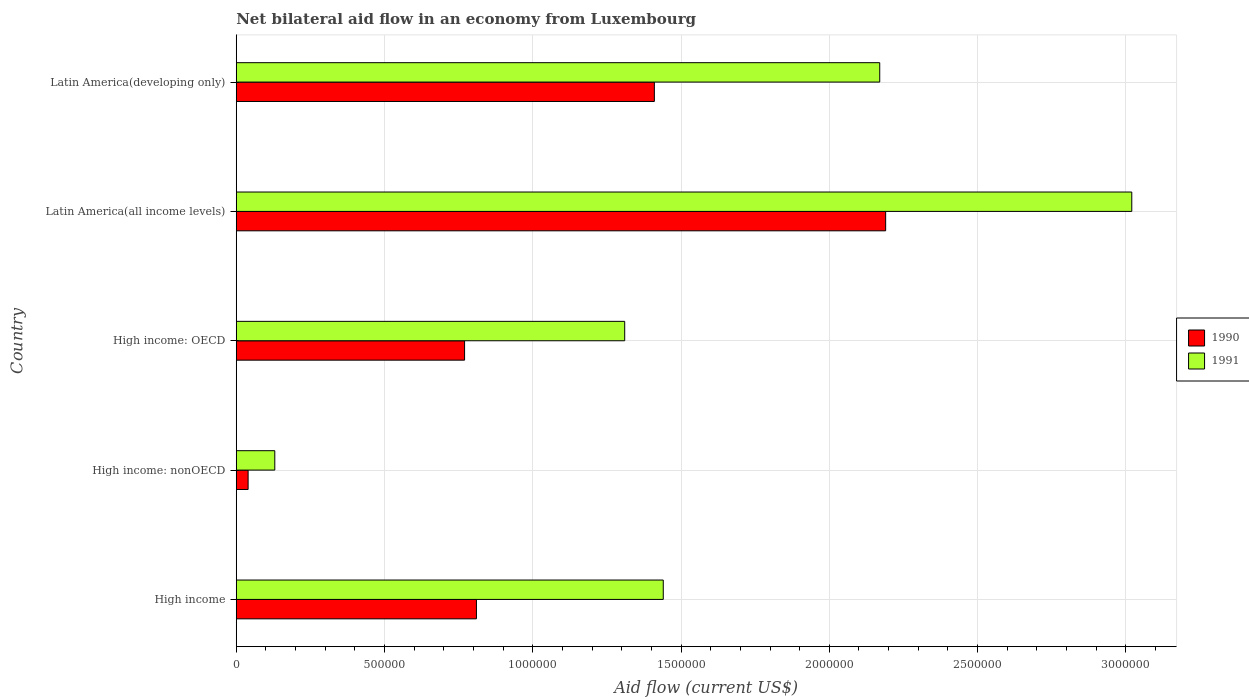How many groups of bars are there?
Ensure brevity in your answer.  5. Are the number of bars per tick equal to the number of legend labels?
Your answer should be compact. Yes. Are the number of bars on each tick of the Y-axis equal?
Your answer should be compact. Yes. How many bars are there on the 1st tick from the top?
Offer a terse response. 2. What is the label of the 1st group of bars from the top?
Your response must be concise. Latin America(developing only). Across all countries, what is the maximum net bilateral aid flow in 1991?
Ensure brevity in your answer.  3.02e+06. In which country was the net bilateral aid flow in 1991 maximum?
Provide a succinct answer. Latin America(all income levels). In which country was the net bilateral aid flow in 1991 minimum?
Give a very brief answer. High income: nonOECD. What is the total net bilateral aid flow in 1990 in the graph?
Offer a terse response. 5.22e+06. What is the difference between the net bilateral aid flow in 1991 in High income and that in Latin America(developing only)?
Keep it short and to the point. -7.30e+05. What is the difference between the net bilateral aid flow in 1990 in Latin America(all income levels) and the net bilateral aid flow in 1991 in High income: OECD?
Provide a short and direct response. 8.80e+05. What is the average net bilateral aid flow in 1991 per country?
Provide a short and direct response. 1.61e+06. What is the difference between the net bilateral aid flow in 1990 and net bilateral aid flow in 1991 in High income: nonOECD?
Give a very brief answer. -9.00e+04. In how many countries, is the net bilateral aid flow in 1990 greater than 1300000 US$?
Your answer should be compact. 2. What is the ratio of the net bilateral aid flow in 1990 in High income: nonOECD to that in Latin America(all income levels)?
Make the answer very short. 0.02. Is the net bilateral aid flow in 1990 in High income: nonOECD less than that in Latin America(developing only)?
Ensure brevity in your answer.  Yes. What is the difference between the highest and the second highest net bilateral aid flow in 1991?
Your answer should be very brief. 8.50e+05. What is the difference between the highest and the lowest net bilateral aid flow in 1990?
Keep it short and to the point. 2.15e+06. Is the sum of the net bilateral aid flow in 1990 in High income and High income: nonOECD greater than the maximum net bilateral aid flow in 1991 across all countries?
Make the answer very short. No. What does the 2nd bar from the top in Latin America(all income levels) represents?
Make the answer very short. 1990. What does the 2nd bar from the bottom in Latin America(developing only) represents?
Keep it short and to the point. 1991. How many countries are there in the graph?
Your answer should be very brief. 5. Are the values on the major ticks of X-axis written in scientific E-notation?
Offer a terse response. No. Does the graph contain any zero values?
Give a very brief answer. No. Does the graph contain grids?
Keep it short and to the point. Yes. Where does the legend appear in the graph?
Give a very brief answer. Center right. How many legend labels are there?
Provide a succinct answer. 2. What is the title of the graph?
Keep it short and to the point. Net bilateral aid flow in an economy from Luxembourg. Does "1984" appear as one of the legend labels in the graph?
Make the answer very short. No. What is the Aid flow (current US$) in 1990 in High income?
Your answer should be compact. 8.10e+05. What is the Aid flow (current US$) of 1991 in High income?
Provide a short and direct response. 1.44e+06. What is the Aid flow (current US$) of 1990 in High income: OECD?
Your answer should be compact. 7.70e+05. What is the Aid flow (current US$) in 1991 in High income: OECD?
Give a very brief answer. 1.31e+06. What is the Aid flow (current US$) in 1990 in Latin America(all income levels)?
Your response must be concise. 2.19e+06. What is the Aid flow (current US$) in 1991 in Latin America(all income levels)?
Offer a terse response. 3.02e+06. What is the Aid flow (current US$) in 1990 in Latin America(developing only)?
Offer a terse response. 1.41e+06. What is the Aid flow (current US$) of 1991 in Latin America(developing only)?
Your answer should be very brief. 2.17e+06. Across all countries, what is the maximum Aid flow (current US$) of 1990?
Give a very brief answer. 2.19e+06. Across all countries, what is the maximum Aid flow (current US$) of 1991?
Your response must be concise. 3.02e+06. Across all countries, what is the minimum Aid flow (current US$) of 1990?
Keep it short and to the point. 4.00e+04. What is the total Aid flow (current US$) of 1990 in the graph?
Your answer should be very brief. 5.22e+06. What is the total Aid flow (current US$) in 1991 in the graph?
Your answer should be very brief. 8.07e+06. What is the difference between the Aid flow (current US$) of 1990 in High income and that in High income: nonOECD?
Offer a terse response. 7.70e+05. What is the difference between the Aid flow (current US$) in 1991 in High income and that in High income: nonOECD?
Your answer should be very brief. 1.31e+06. What is the difference between the Aid flow (current US$) in 1990 in High income and that in High income: OECD?
Your answer should be compact. 4.00e+04. What is the difference between the Aid flow (current US$) of 1990 in High income and that in Latin America(all income levels)?
Keep it short and to the point. -1.38e+06. What is the difference between the Aid flow (current US$) in 1991 in High income and that in Latin America(all income levels)?
Provide a short and direct response. -1.58e+06. What is the difference between the Aid flow (current US$) of 1990 in High income and that in Latin America(developing only)?
Make the answer very short. -6.00e+05. What is the difference between the Aid flow (current US$) in 1991 in High income and that in Latin America(developing only)?
Your answer should be compact. -7.30e+05. What is the difference between the Aid flow (current US$) in 1990 in High income: nonOECD and that in High income: OECD?
Your answer should be very brief. -7.30e+05. What is the difference between the Aid flow (current US$) in 1991 in High income: nonOECD and that in High income: OECD?
Ensure brevity in your answer.  -1.18e+06. What is the difference between the Aid flow (current US$) of 1990 in High income: nonOECD and that in Latin America(all income levels)?
Your answer should be compact. -2.15e+06. What is the difference between the Aid flow (current US$) in 1991 in High income: nonOECD and that in Latin America(all income levels)?
Give a very brief answer. -2.89e+06. What is the difference between the Aid flow (current US$) of 1990 in High income: nonOECD and that in Latin America(developing only)?
Provide a succinct answer. -1.37e+06. What is the difference between the Aid flow (current US$) in 1991 in High income: nonOECD and that in Latin America(developing only)?
Offer a terse response. -2.04e+06. What is the difference between the Aid flow (current US$) in 1990 in High income: OECD and that in Latin America(all income levels)?
Your response must be concise. -1.42e+06. What is the difference between the Aid flow (current US$) of 1991 in High income: OECD and that in Latin America(all income levels)?
Keep it short and to the point. -1.71e+06. What is the difference between the Aid flow (current US$) in 1990 in High income: OECD and that in Latin America(developing only)?
Offer a very short reply. -6.40e+05. What is the difference between the Aid flow (current US$) of 1991 in High income: OECD and that in Latin America(developing only)?
Provide a succinct answer. -8.60e+05. What is the difference between the Aid flow (current US$) of 1990 in Latin America(all income levels) and that in Latin America(developing only)?
Offer a very short reply. 7.80e+05. What is the difference between the Aid flow (current US$) of 1991 in Latin America(all income levels) and that in Latin America(developing only)?
Give a very brief answer. 8.50e+05. What is the difference between the Aid flow (current US$) in 1990 in High income and the Aid flow (current US$) in 1991 in High income: nonOECD?
Your answer should be very brief. 6.80e+05. What is the difference between the Aid flow (current US$) in 1990 in High income and the Aid flow (current US$) in 1991 in High income: OECD?
Provide a short and direct response. -5.00e+05. What is the difference between the Aid flow (current US$) in 1990 in High income and the Aid flow (current US$) in 1991 in Latin America(all income levels)?
Provide a short and direct response. -2.21e+06. What is the difference between the Aid flow (current US$) of 1990 in High income and the Aid flow (current US$) of 1991 in Latin America(developing only)?
Make the answer very short. -1.36e+06. What is the difference between the Aid flow (current US$) of 1990 in High income: nonOECD and the Aid flow (current US$) of 1991 in High income: OECD?
Give a very brief answer. -1.27e+06. What is the difference between the Aid flow (current US$) in 1990 in High income: nonOECD and the Aid flow (current US$) in 1991 in Latin America(all income levels)?
Provide a short and direct response. -2.98e+06. What is the difference between the Aid flow (current US$) of 1990 in High income: nonOECD and the Aid flow (current US$) of 1991 in Latin America(developing only)?
Give a very brief answer. -2.13e+06. What is the difference between the Aid flow (current US$) of 1990 in High income: OECD and the Aid flow (current US$) of 1991 in Latin America(all income levels)?
Your answer should be compact. -2.25e+06. What is the difference between the Aid flow (current US$) of 1990 in High income: OECD and the Aid flow (current US$) of 1991 in Latin America(developing only)?
Your answer should be very brief. -1.40e+06. What is the average Aid flow (current US$) in 1990 per country?
Your answer should be very brief. 1.04e+06. What is the average Aid flow (current US$) in 1991 per country?
Give a very brief answer. 1.61e+06. What is the difference between the Aid flow (current US$) of 1990 and Aid flow (current US$) of 1991 in High income?
Offer a very short reply. -6.30e+05. What is the difference between the Aid flow (current US$) of 1990 and Aid flow (current US$) of 1991 in High income: nonOECD?
Your answer should be compact. -9.00e+04. What is the difference between the Aid flow (current US$) in 1990 and Aid flow (current US$) in 1991 in High income: OECD?
Give a very brief answer. -5.40e+05. What is the difference between the Aid flow (current US$) in 1990 and Aid flow (current US$) in 1991 in Latin America(all income levels)?
Give a very brief answer. -8.30e+05. What is the difference between the Aid flow (current US$) in 1990 and Aid flow (current US$) in 1991 in Latin America(developing only)?
Your response must be concise. -7.60e+05. What is the ratio of the Aid flow (current US$) in 1990 in High income to that in High income: nonOECD?
Make the answer very short. 20.25. What is the ratio of the Aid flow (current US$) of 1991 in High income to that in High income: nonOECD?
Your response must be concise. 11.08. What is the ratio of the Aid flow (current US$) of 1990 in High income to that in High income: OECD?
Make the answer very short. 1.05. What is the ratio of the Aid flow (current US$) of 1991 in High income to that in High income: OECD?
Provide a short and direct response. 1.1. What is the ratio of the Aid flow (current US$) of 1990 in High income to that in Latin America(all income levels)?
Your response must be concise. 0.37. What is the ratio of the Aid flow (current US$) in 1991 in High income to that in Latin America(all income levels)?
Your answer should be very brief. 0.48. What is the ratio of the Aid flow (current US$) of 1990 in High income to that in Latin America(developing only)?
Your response must be concise. 0.57. What is the ratio of the Aid flow (current US$) of 1991 in High income to that in Latin America(developing only)?
Make the answer very short. 0.66. What is the ratio of the Aid flow (current US$) in 1990 in High income: nonOECD to that in High income: OECD?
Make the answer very short. 0.05. What is the ratio of the Aid flow (current US$) in 1991 in High income: nonOECD to that in High income: OECD?
Make the answer very short. 0.1. What is the ratio of the Aid flow (current US$) in 1990 in High income: nonOECD to that in Latin America(all income levels)?
Keep it short and to the point. 0.02. What is the ratio of the Aid flow (current US$) of 1991 in High income: nonOECD to that in Latin America(all income levels)?
Your response must be concise. 0.04. What is the ratio of the Aid flow (current US$) in 1990 in High income: nonOECD to that in Latin America(developing only)?
Your answer should be compact. 0.03. What is the ratio of the Aid flow (current US$) of 1991 in High income: nonOECD to that in Latin America(developing only)?
Offer a terse response. 0.06. What is the ratio of the Aid flow (current US$) in 1990 in High income: OECD to that in Latin America(all income levels)?
Your answer should be very brief. 0.35. What is the ratio of the Aid flow (current US$) in 1991 in High income: OECD to that in Latin America(all income levels)?
Provide a succinct answer. 0.43. What is the ratio of the Aid flow (current US$) in 1990 in High income: OECD to that in Latin America(developing only)?
Offer a terse response. 0.55. What is the ratio of the Aid flow (current US$) in 1991 in High income: OECD to that in Latin America(developing only)?
Offer a terse response. 0.6. What is the ratio of the Aid flow (current US$) in 1990 in Latin America(all income levels) to that in Latin America(developing only)?
Ensure brevity in your answer.  1.55. What is the ratio of the Aid flow (current US$) of 1991 in Latin America(all income levels) to that in Latin America(developing only)?
Keep it short and to the point. 1.39. What is the difference between the highest and the second highest Aid flow (current US$) of 1990?
Offer a very short reply. 7.80e+05. What is the difference between the highest and the second highest Aid flow (current US$) in 1991?
Provide a short and direct response. 8.50e+05. What is the difference between the highest and the lowest Aid flow (current US$) in 1990?
Ensure brevity in your answer.  2.15e+06. What is the difference between the highest and the lowest Aid flow (current US$) of 1991?
Provide a succinct answer. 2.89e+06. 